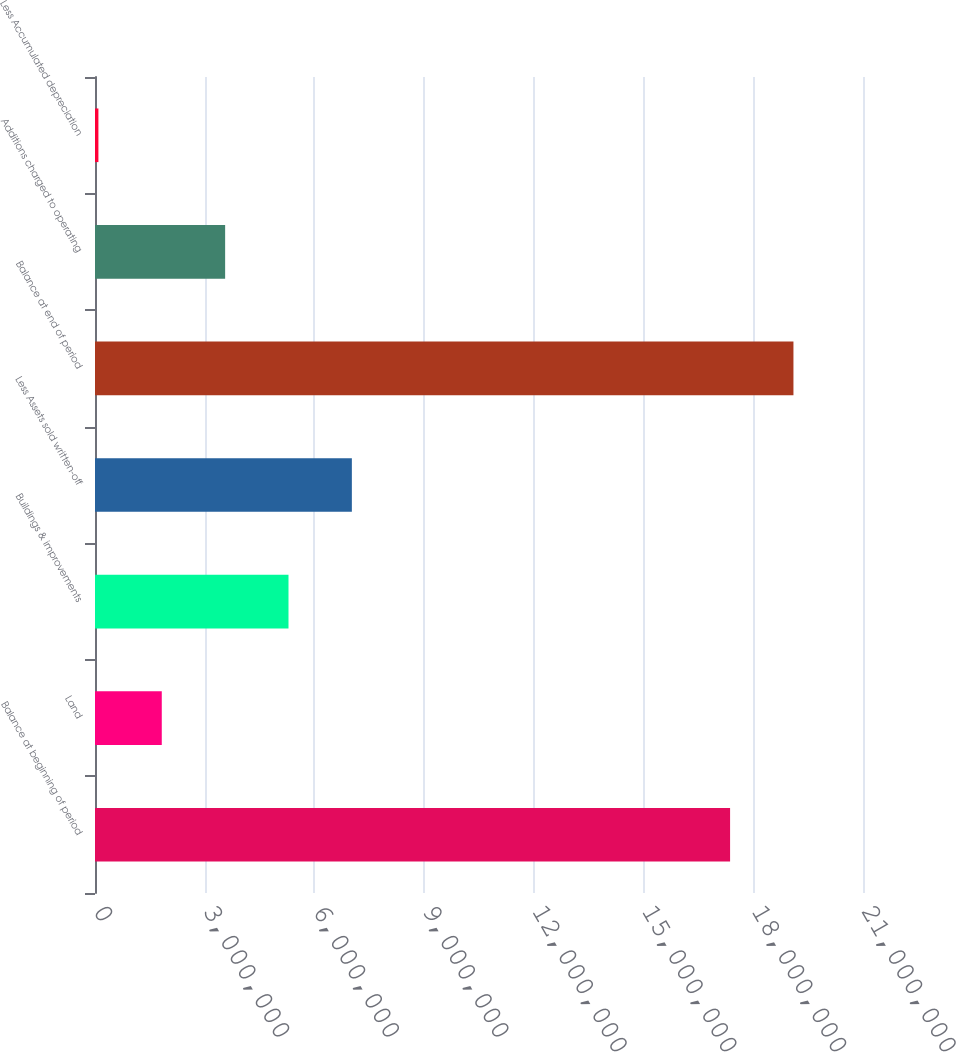<chart> <loc_0><loc_0><loc_500><loc_500><bar_chart><fcel>Balance at beginning of period<fcel>Land<fcel>Buildings & improvements<fcel>Less Assets sold written-off<fcel>Balance at end of period<fcel>Additions charged to operating<fcel>Less Accumulated depreciation<nl><fcel>1.73655e+07<fcel>1.82577e+06<fcel>5.29092e+06<fcel>7.02349e+06<fcel>1.90981e+07<fcel>3.55834e+06<fcel>93194<nl></chart> 